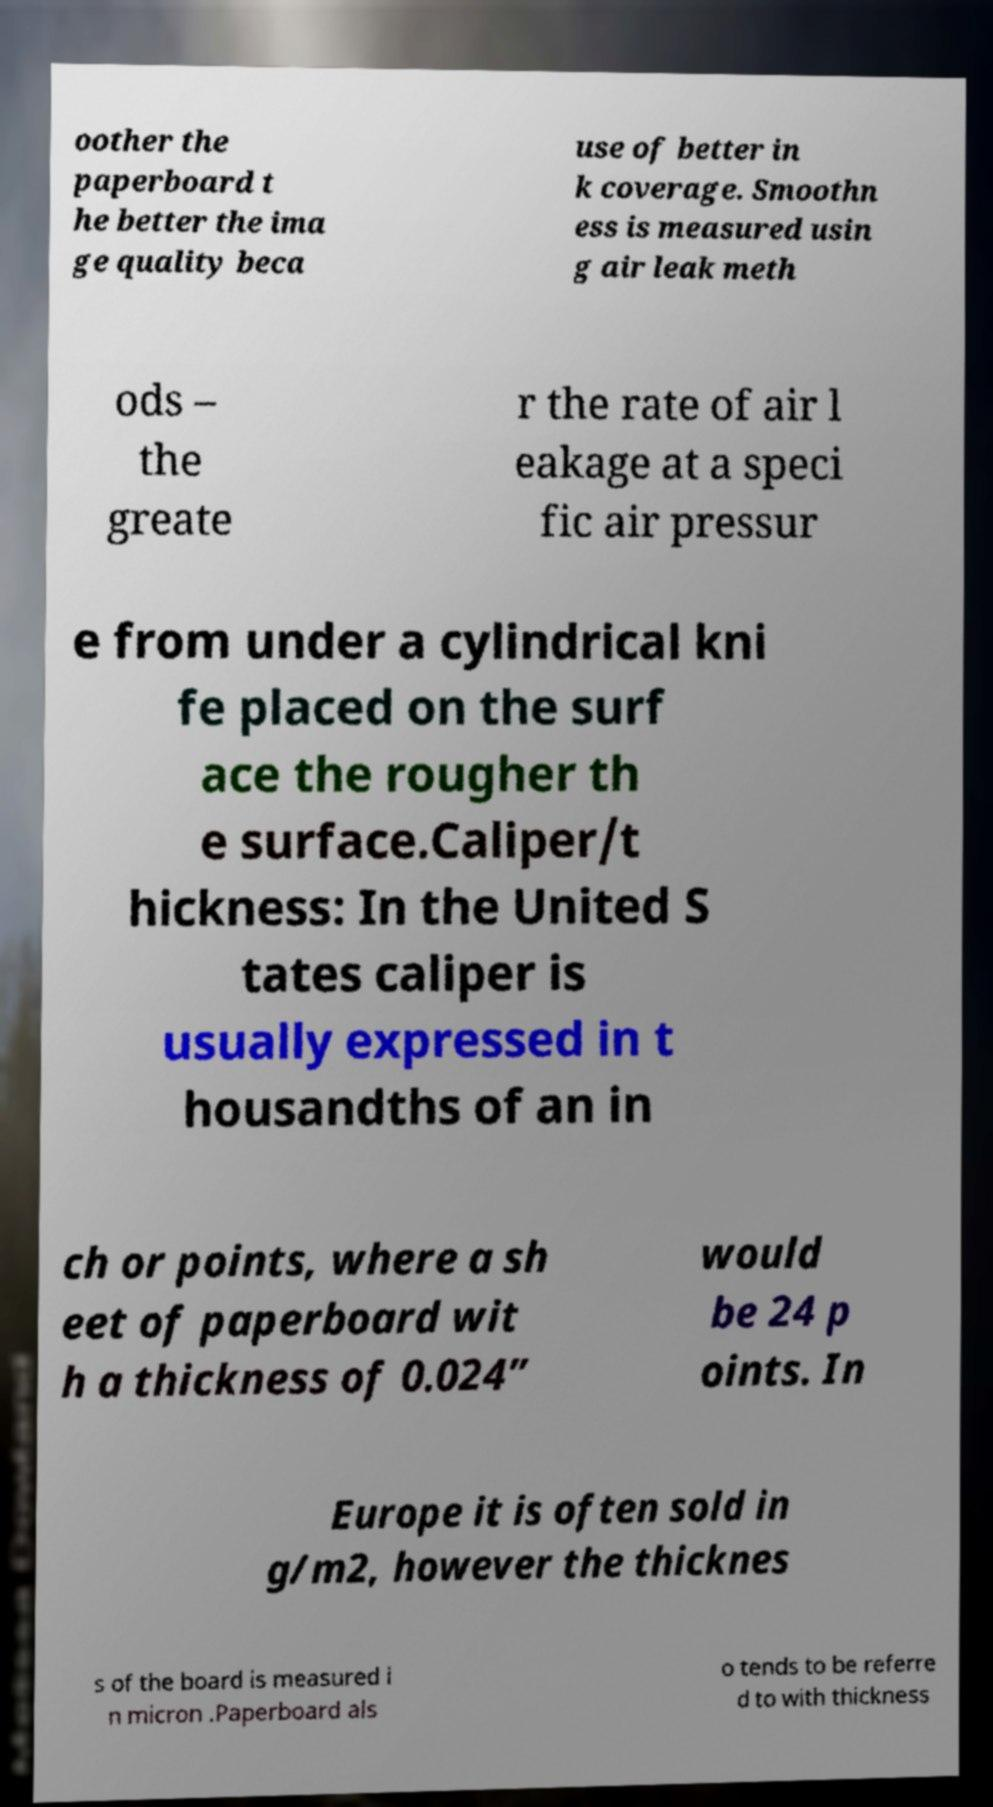What messages or text are displayed in this image? I need them in a readable, typed format. oother the paperboard t he better the ima ge quality beca use of better in k coverage. Smoothn ess is measured usin g air leak meth ods – the greate r the rate of air l eakage at a speci fic air pressur e from under a cylindrical kni fe placed on the surf ace the rougher th e surface.Caliper/t hickness: In the United S tates caliper is usually expressed in t housandths of an in ch or points, where a sh eet of paperboard wit h a thickness of 0.024” would be 24 p oints. In Europe it is often sold in g/m2, however the thicknes s of the board is measured i n micron .Paperboard als o tends to be referre d to with thickness 